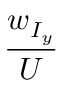<formula> <loc_0><loc_0><loc_500><loc_500>\frac { w _ { I _ { y } } } { U }</formula> 